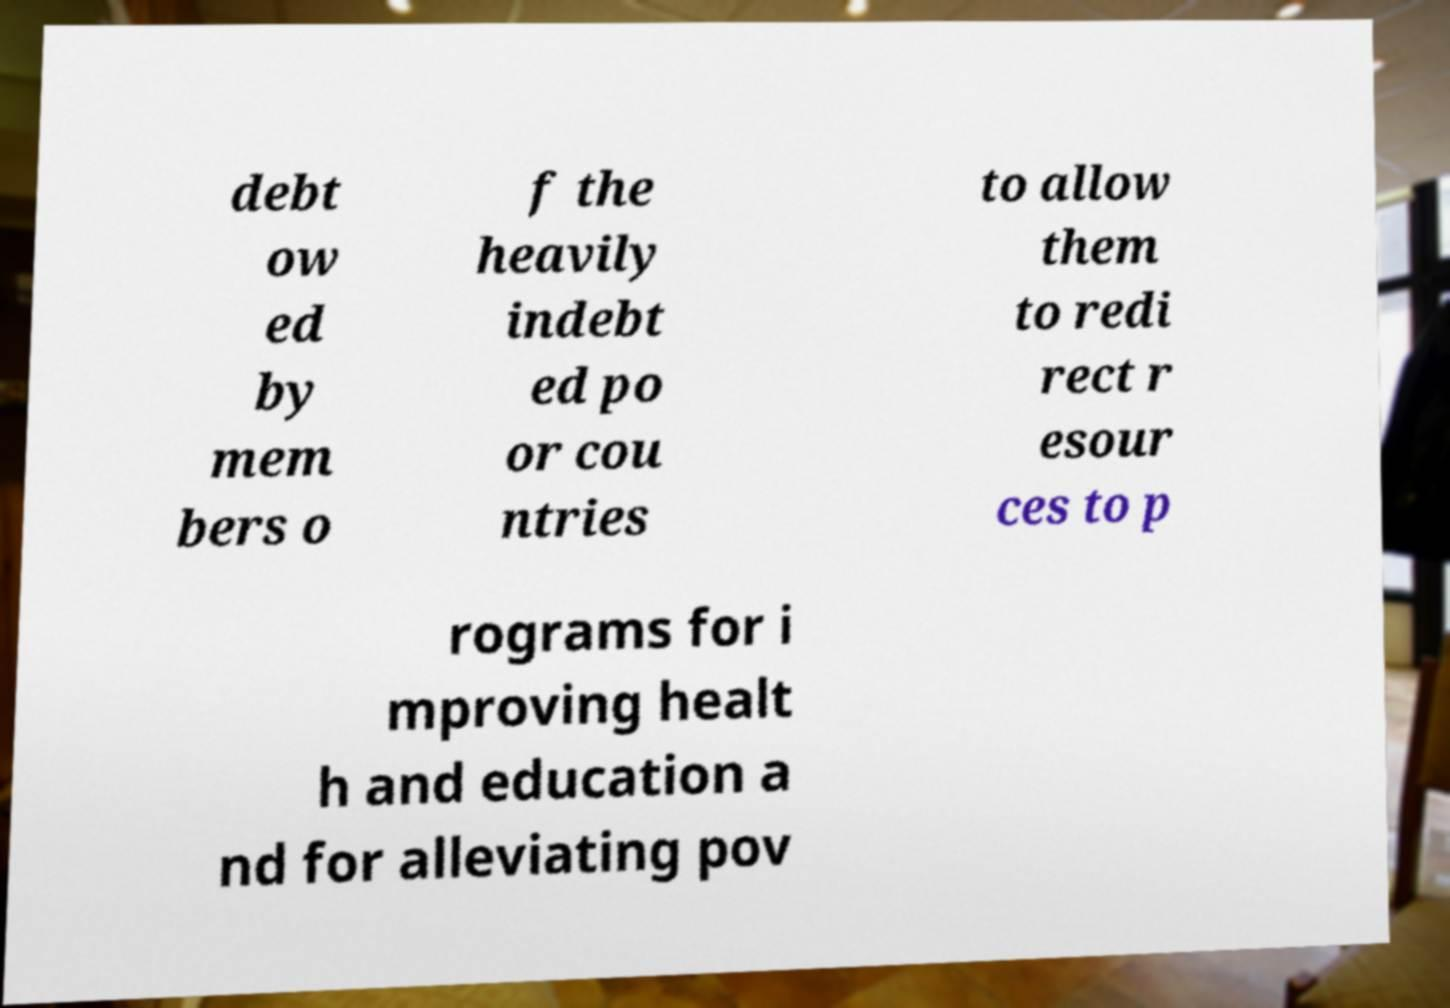There's text embedded in this image that I need extracted. Can you transcribe it verbatim? debt ow ed by mem bers o f the heavily indebt ed po or cou ntries to allow them to redi rect r esour ces to p rograms for i mproving healt h and education a nd for alleviating pov 